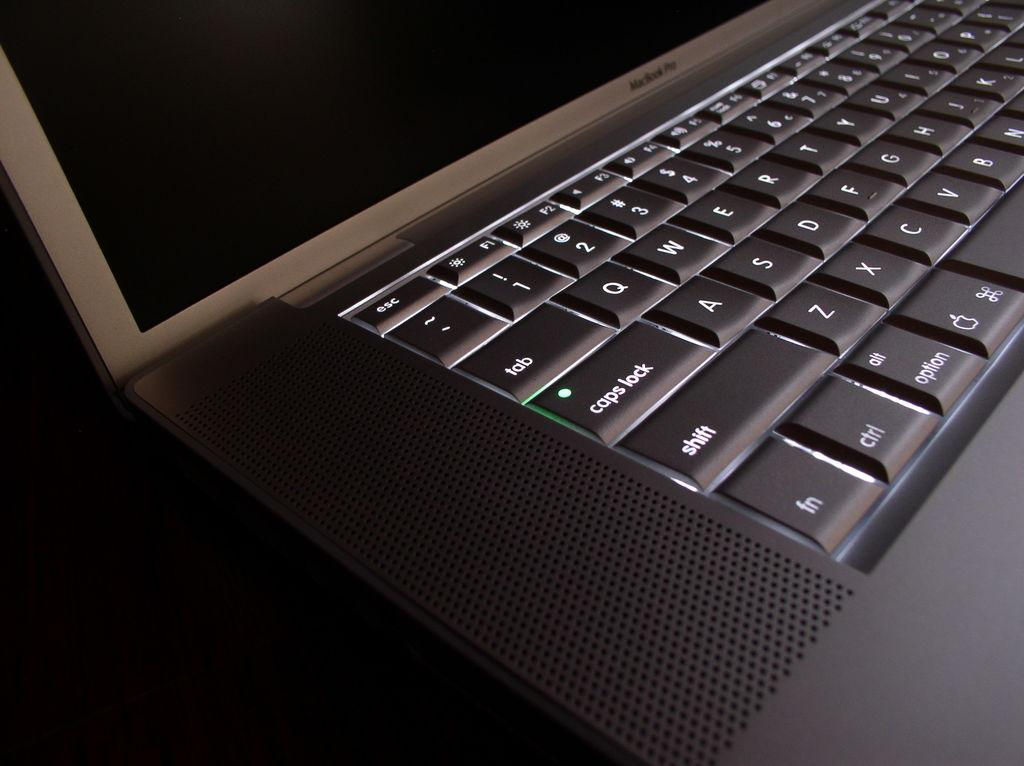<image>
Offer a succinct explanation of the picture presented. The black laptop has a caps lock key lit up 